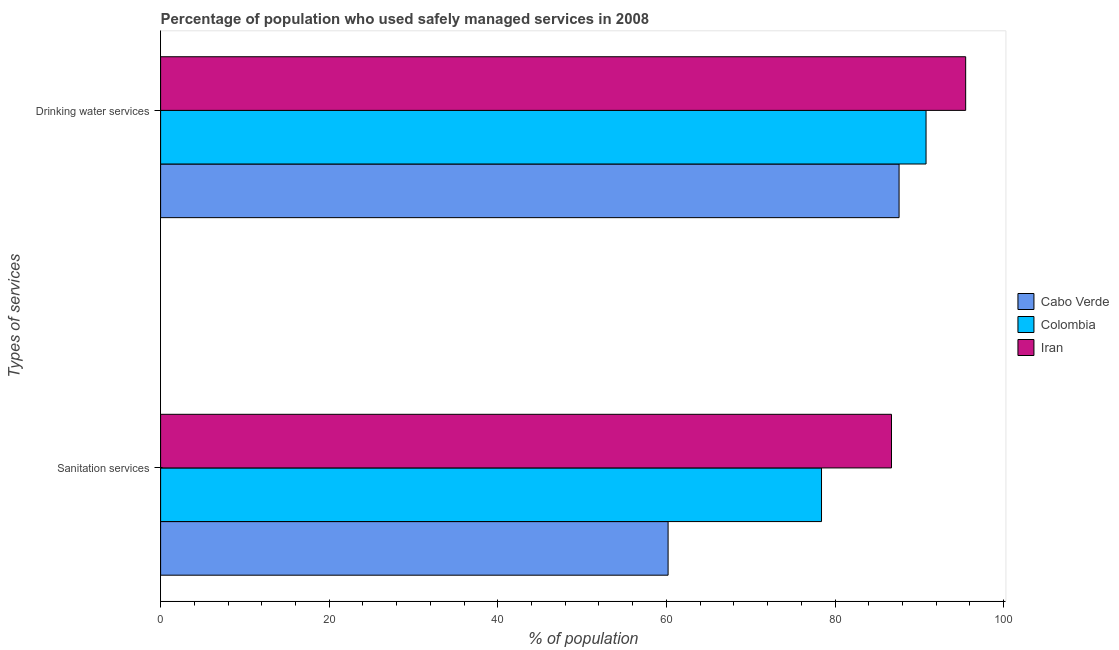How many different coloured bars are there?
Your response must be concise. 3. How many groups of bars are there?
Your response must be concise. 2. Are the number of bars per tick equal to the number of legend labels?
Your response must be concise. Yes. How many bars are there on the 1st tick from the top?
Your answer should be compact. 3. What is the label of the 1st group of bars from the top?
Your answer should be compact. Drinking water services. What is the percentage of population who used sanitation services in Colombia?
Offer a very short reply. 78.4. Across all countries, what is the maximum percentage of population who used drinking water services?
Provide a short and direct response. 95.5. Across all countries, what is the minimum percentage of population who used drinking water services?
Offer a terse response. 87.6. In which country was the percentage of population who used sanitation services maximum?
Offer a terse response. Iran. In which country was the percentage of population who used drinking water services minimum?
Your answer should be very brief. Cabo Verde. What is the total percentage of population who used sanitation services in the graph?
Provide a succinct answer. 225.3. What is the difference between the percentage of population who used sanitation services in Colombia and that in Iran?
Your answer should be compact. -8.3. What is the difference between the percentage of population who used sanitation services in Colombia and the percentage of population who used drinking water services in Iran?
Your response must be concise. -17.1. What is the average percentage of population who used drinking water services per country?
Make the answer very short. 91.3. What is the difference between the percentage of population who used sanitation services and percentage of population who used drinking water services in Cabo Verde?
Give a very brief answer. -27.4. What is the ratio of the percentage of population who used sanitation services in Cabo Verde to that in Iran?
Offer a very short reply. 0.69. Is the percentage of population who used drinking water services in Iran less than that in Colombia?
Offer a terse response. No. What does the 1st bar from the top in Sanitation services represents?
Offer a very short reply. Iran. What does the 3rd bar from the bottom in Drinking water services represents?
Your answer should be compact. Iran. What is the difference between two consecutive major ticks on the X-axis?
Your response must be concise. 20. Are the values on the major ticks of X-axis written in scientific E-notation?
Offer a very short reply. No. Does the graph contain any zero values?
Make the answer very short. No. How many legend labels are there?
Keep it short and to the point. 3. What is the title of the graph?
Provide a short and direct response. Percentage of population who used safely managed services in 2008. What is the label or title of the X-axis?
Your answer should be compact. % of population. What is the label or title of the Y-axis?
Your answer should be very brief. Types of services. What is the % of population in Cabo Verde in Sanitation services?
Provide a short and direct response. 60.2. What is the % of population in Colombia in Sanitation services?
Offer a terse response. 78.4. What is the % of population of Iran in Sanitation services?
Offer a very short reply. 86.7. What is the % of population of Cabo Verde in Drinking water services?
Keep it short and to the point. 87.6. What is the % of population in Colombia in Drinking water services?
Offer a terse response. 90.8. What is the % of population in Iran in Drinking water services?
Offer a very short reply. 95.5. Across all Types of services, what is the maximum % of population in Cabo Verde?
Keep it short and to the point. 87.6. Across all Types of services, what is the maximum % of population in Colombia?
Make the answer very short. 90.8. Across all Types of services, what is the maximum % of population of Iran?
Ensure brevity in your answer.  95.5. Across all Types of services, what is the minimum % of population in Cabo Verde?
Keep it short and to the point. 60.2. Across all Types of services, what is the minimum % of population in Colombia?
Your answer should be very brief. 78.4. Across all Types of services, what is the minimum % of population of Iran?
Make the answer very short. 86.7. What is the total % of population in Cabo Verde in the graph?
Your answer should be very brief. 147.8. What is the total % of population of Colombia in the graph?
Your answer should be compact. 169.2. What is the total % of population in Iran in the graph?
Give a very brief answer. 182.2. What is the difference between the % of population in Cabo Verde in Sanitation services and that in Drinking water services?
Make the answer very short. -27.4. What is the difference between the % of population in Iran in Sanitation services and that in Drinking water services?
Your answer should be compact. -8.8. What is the difference between the % of population in Cabo Verde in Sanitation services and the % of population in Colombia in Drinking water services?
Offer a very short reply. -30.6. What is the difference between the % of population in Cabo Verde in Sanitation services and the % of population in Iran in Drinking water services?
Provide a succinct answer. -35.3. What is the difference between the % of population in Colombia in Sanitation services and the % of population in Iran in Drinking water services?
Make the answer very short. -17.1. What is the average % of population in Cabo Verde per Types of services?
Provide a succinct answer. 73.9. What is the average % of population in Colombia per Types of services?
Offer a terse response. 84.6. What is the average % of population of Iran per Types of services?
Offer a terse response. 91.1. What is the difference between the % of population in Cabo Verde and % of population in Colombia in Sanitation services?
Keep it short and to the point. -18.2. What is the difference between the % of population of Cabo Verde and % of population of Iran in Sanitation services?
Provide a succinct answer. -26.5. What is the difference between the % of population of Cabo Verde and % of population of Colombia in Drinking water services?
Make the answer very short. -3.2. What is the ratio of the % of population of Cabo Verde in Sanitation services to that in Drinking water services?
Offer a terse response. 0.69. What is the ratio of the % of population of Colombia in Sanitation services to that in Drinking water services?
Ensure brevity in your answer.  0.86. What is the ratio of the % of population of Iran in Sanitation services to that in Drinking water services?
Provide a short and direct response. 0.91. What is the difference between the highest and the second highest % of population in Cabo Verde?
Offer a terse response. 27.4. What is the difference between the highest and the second highest % of population in Colombia?
Keep it short and to the point. 12.4. What is the difference between the highest and the lowest % of population of Cabo Verde?
Offer a terse response. 27.4. 